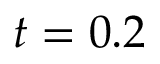<formula> <loc_0><loc_0><loc_500><loc_500>t = 0 . 2</formula> 